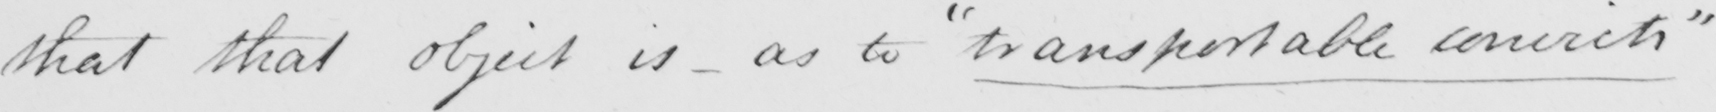Can you tell me what this handwritten text says? that that object is  _  as to  " transportable convicts " 